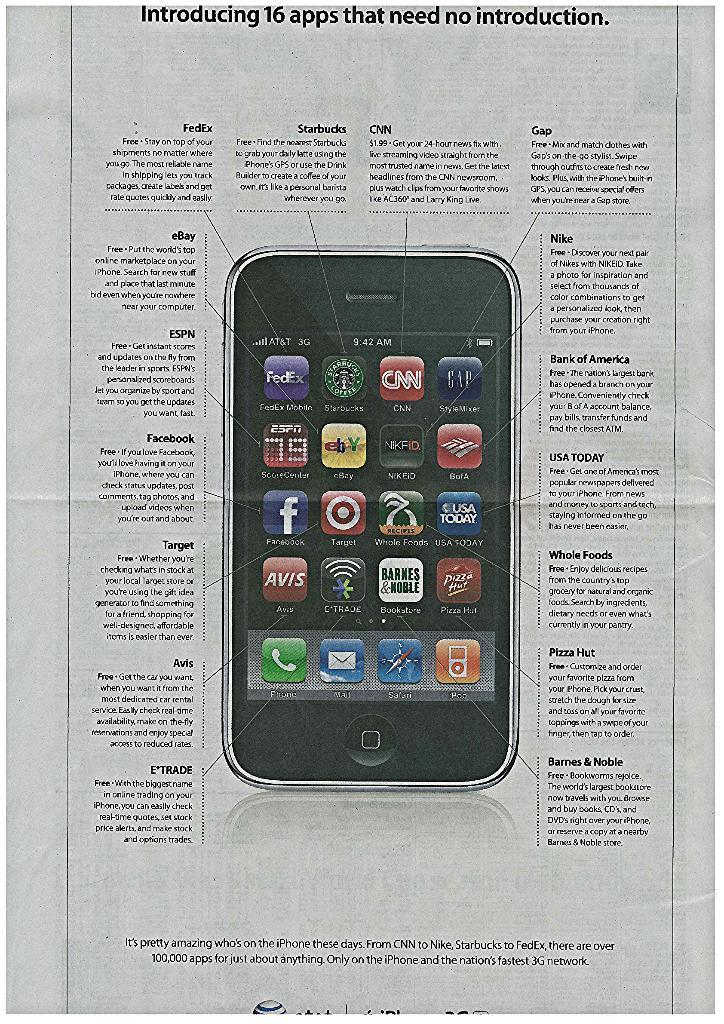<image>
Describe the image concisely. An ad about a phone that is describing its apps. 